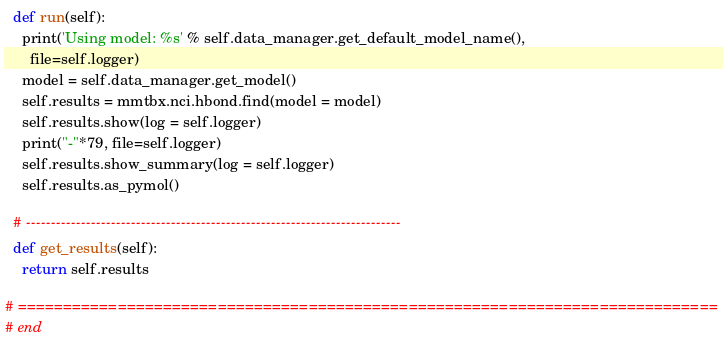<code> <loc_0><loc_0><loc_500><loc_500><_Python_>  def run(self):
    print('Using model: %s' % self.data_manager.get_default_model_name(),
      file=self.logger)
    model = self.data_manager.get_model()
    self.results = mmtbx.nci.hbond.find(model = model)
    self.results.show(log = self.logger)
    print("-"*79, file=self.logger)
    self.results.show_summary(log = self.logger)
    self.results.as_pymol()

  # ---------------------------------------------------------------------------
  def get_results(self):
    return self.results

# =============================================================================
# end
</code> 